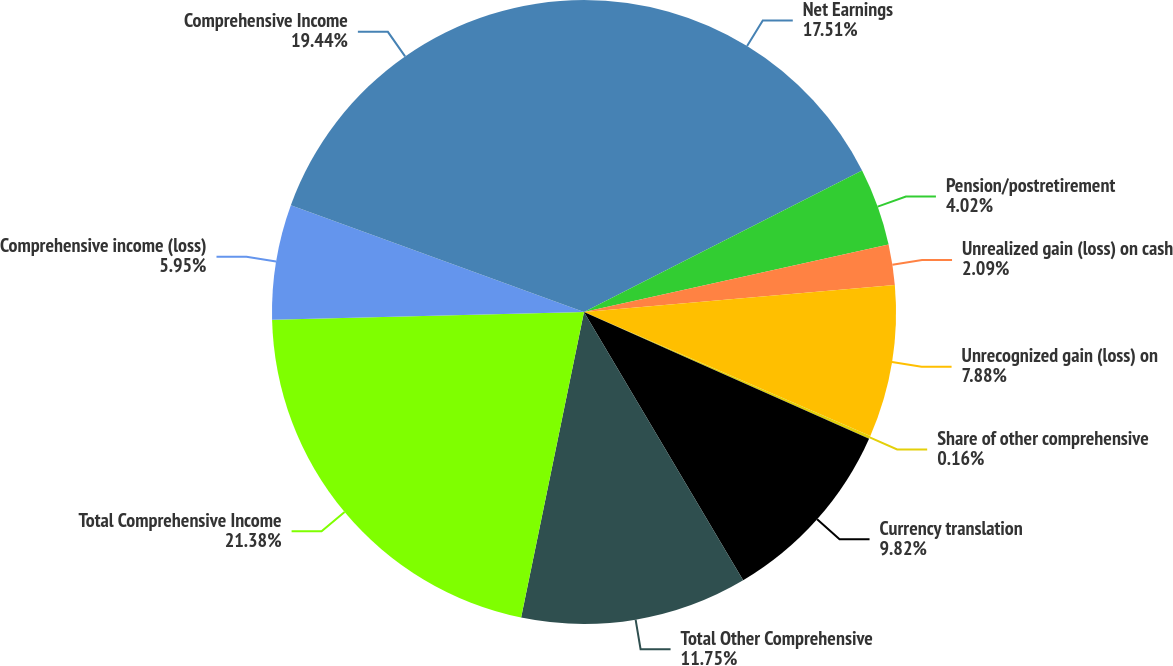Convert chart to OTSL. <chart><loc_0><loc_0><loc_500><loc_500><pie_chart><fcel>Net Earnings<fcel>Pension/postretirement<fcel>Unrealized gain (loss) on cash<fcel>Unrecognized gain (loss) on<fcel>Share of other comprehensive<fcel>Currency translation<fcel>Total Other Comprehensive<fcel>Total Comprehensive Income<fcel>Comprehensive income (loss)<fcel>Comprehensive Income<nl><fcel>17.51%<fcel>4.02%<fcel>2.09%<fcel>7.88%<fcel>0.16%<fcel>9.82%<fcel>11.75%<fcel>21.38%<fcel>5.95%<fcel>19.44%<nl></chart> 